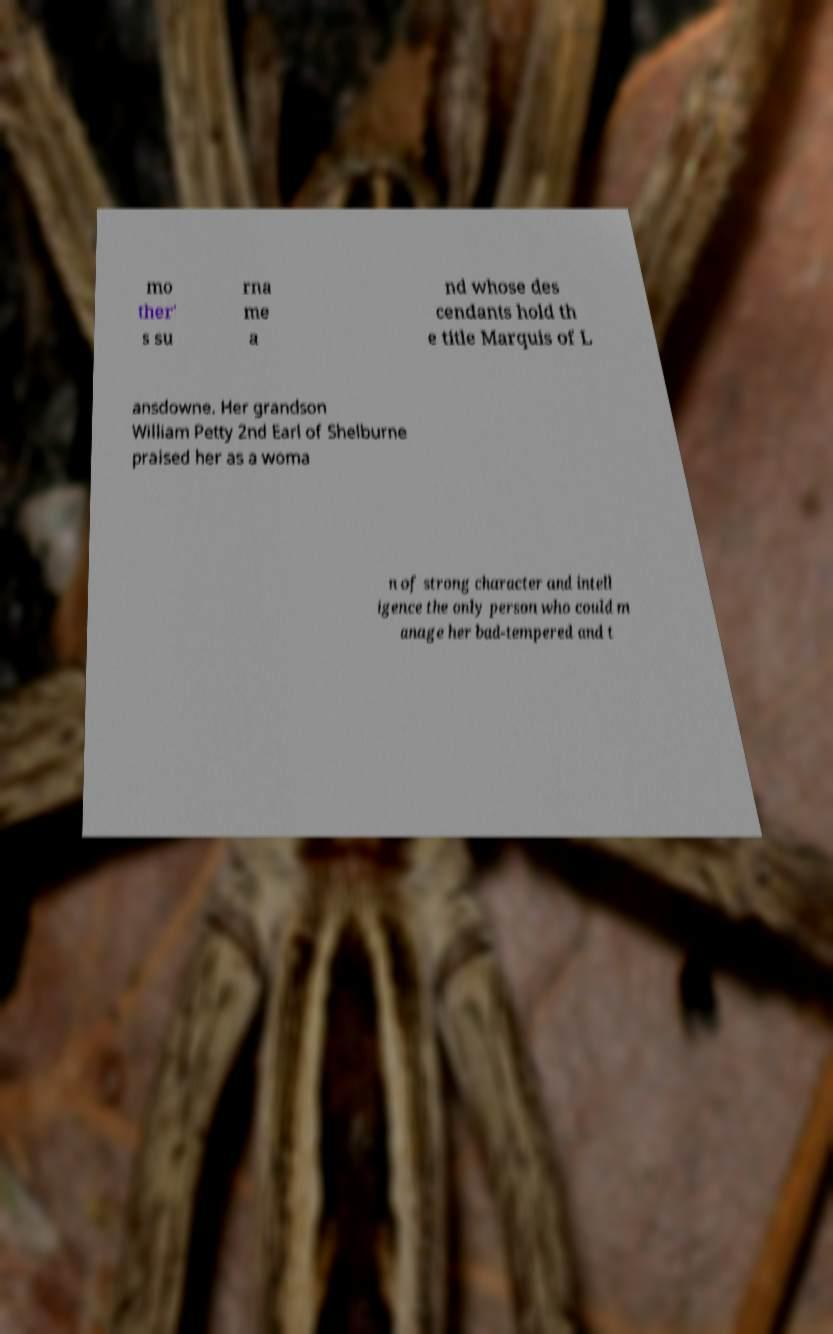Could you assist in decoding the text presented in this image and type it out clearly? mo ther' s su rna me a nd whose des cendants hold th e title Marquis of L ansdowne. Her grandson William Petty 2nd Earl of Shelburne praised her as a woma n of strong character and intell igence the only person who could m anage her bad-tempered and t 